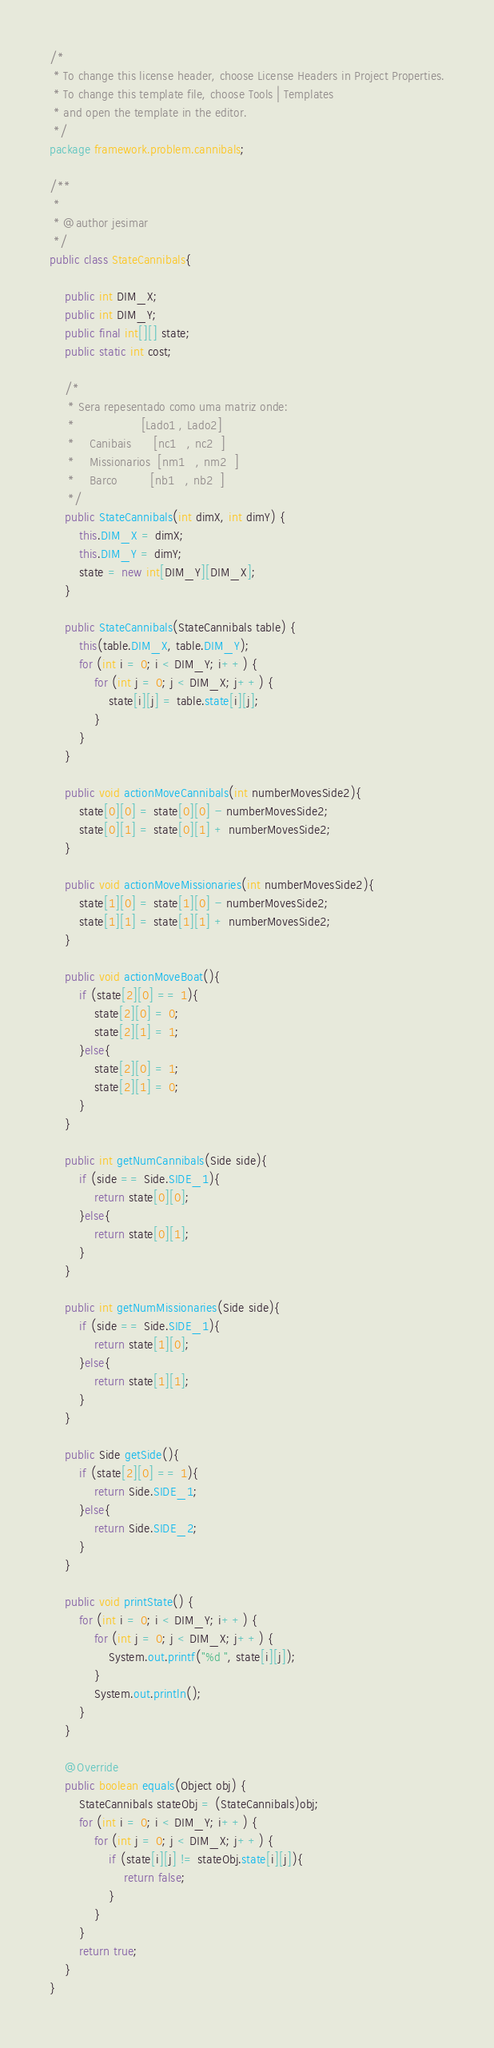Convert code to text. <code><loc_0><loc_0><loc_500><loc_500><_Java_>/*
 * To change this license header, choose License Headers in Project Properties.
 * To change this template file, choose Tools | Templates
 * and open the template in the editor.
 */
package framework.problem.cannibals;

/**
 *
 * @author jesimar
 */
public class StateCannibals{
    
    public int DIM_X;
    public int DIM_Y;
    public final int[][] state;
    public static int cost;
    
    /*
     * Sera repesentado como uma matriz onde: 
     *                  [Lado1 , Lado2]
     *    Canibais      [nc1   , nc2  ]
     *    Missionarios  [nm1   , nm2  ]
     *    Barco         [nb1   , nb2  ]
     */
    public StateCannibals(int dimX, int dimY) {
        this.DIM_X = dimX;
        this.DIM_Y = dimY;
        state = new int[DIM_Y][DIM_X];
    }
    
    public StateCannibals(StateCannibals table) {
        this(table.DIM_X, table.DIM_Y);
        for (int i = 0; i < DIM_Y; i++) {
            for (int j = 0; j < DIM_X; j++) {
                state[i][j] = table.state[i][j];
            }
        }        
    }
    
    public void actionMoveCannibals(int numberMovesSide2){
        state[0][0] = state[0][0] - numberMovesSide2;
        state[0][1] = state[0][1] + numberMovesSide2;
    }
    
    public void actionMoveMissionaries(int numberMovesSide2){
        state[1][0] = state[1][0] - numberMovesSide2;
        state[1][1] = state[1][1] + numberMovesSide2;
    }
    
    public void actionMoveBoat(){
        if (state[2][0] == 1){
            state[2][0] = 0;
            state[2][1] = 1;
        }else{
            state[2][0] = 1;
            state[2][1] = 0;
        }
    }
    
    public int getNumCannibals(Side side){
        if (side == Side.SIDE_1){
            return state[0][0];
        }else{
            return state[0][1];
        }
    }
    
    public int getNumMissionaries(Side side){
        if (side == Side.SIDE_1){
            return state[1][0];
        }else{
            return state[1][1];
        }
    }
    
    public Side getSide(){
        if (state[2][0] == 1){
            return Side.SIDE_1;
        }else{
            return Side.SIDE_2;
        }
    }
    
    public void printState() {
        for (int i = 0; i < DIM_Y; i++) {
            for (int j = 0; j < DIM_X; j++) {
                System.out.printf("%d ", state[i][j]);
            }
            System.out.println();
        }
    }

    @Override
    public boolean equals(Object obj) {
        StateCannibals stateObj = (StateCannibals)obj;        
        for (int i = 0; i < DIM_Y; i++) {
            for (int j = 0; j < DIM_X; j++) {
                if (state[i][j] != stateObj.state[i][j]){
                    return false;
                }
            }
        }
        return true;
    }        
}
</code> 